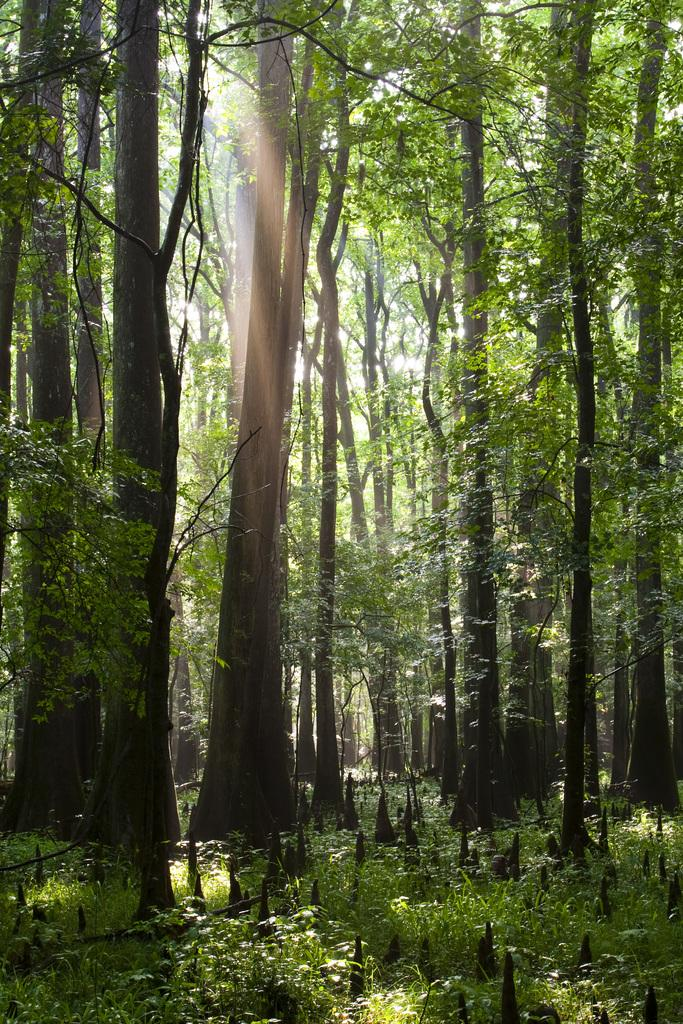What type of vegetation is present in the image? There is grass in the image. What color are the objects on the ground? The objects on the ground are black colored. What colors are the trees in the image? The trees in the image are green and black. What can be seen in the background of the image? The sky is visible in the background of the image. What type of cap is the man wearing in the image? There are no men or caps present in the image. What religious symbols can be seen in the image? There are no religious symbols present in the image. 